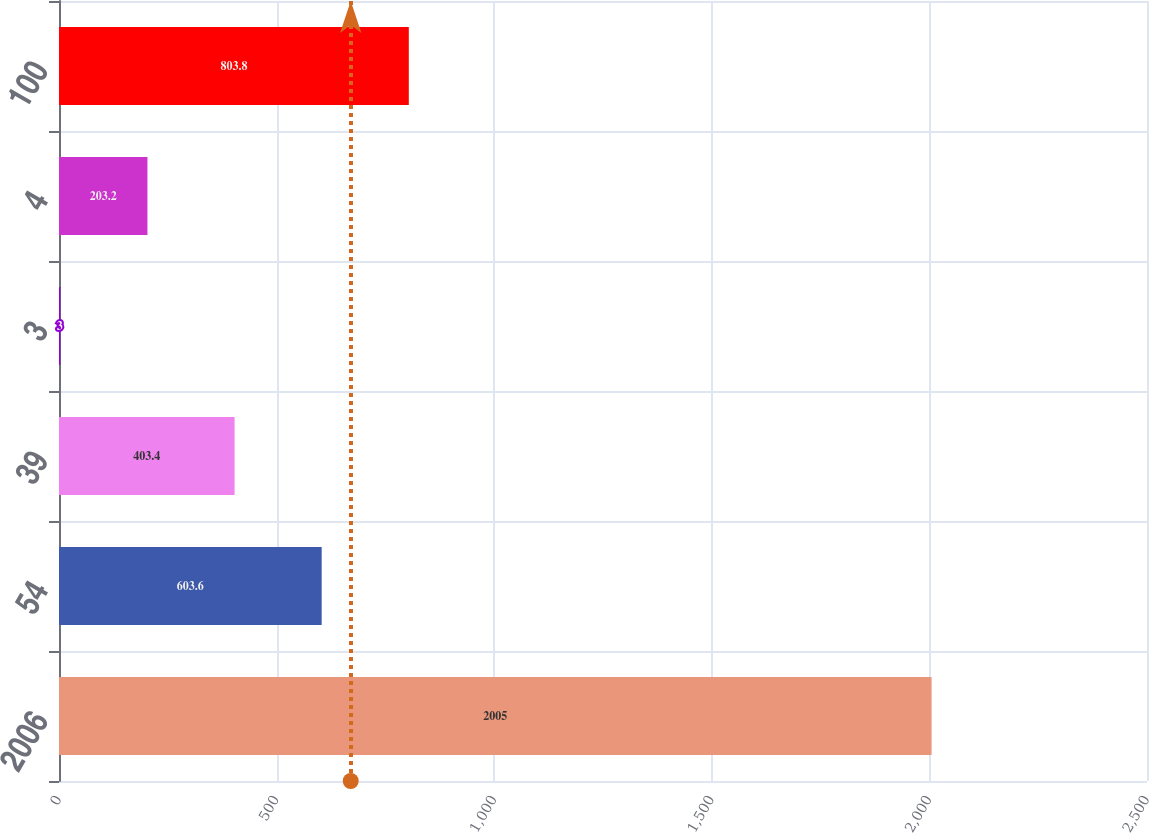<chart> <loc_0><loc_0><loc_500><loc_500><bar_chart><fcel>2006<fcel>54<fcel>39<fcel>3<fcel>4<fcel>100<nl><fcel>2005<fcel>603.6<fcel>403.4<fcel>3<fcel>203.2<fcel>803.8<nl></chart> 